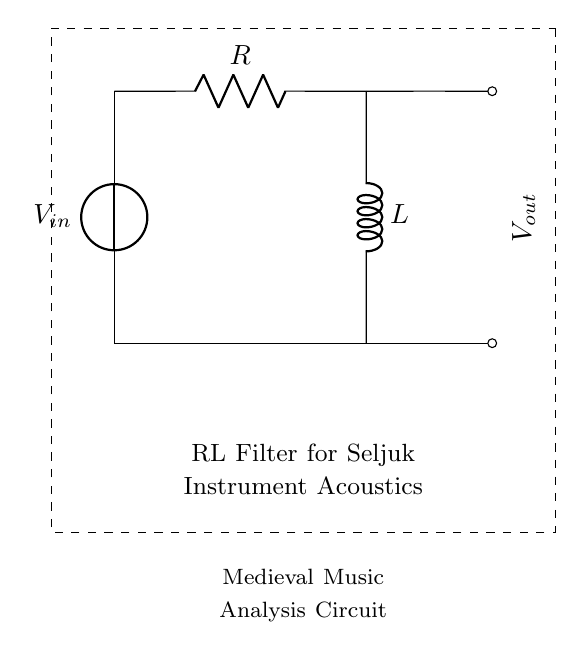What are the components in the circuit? In the circuit, the two primary components are a resistor and an inductor, as indicated by their respective symbols labeled R and L.
Answer: resistor and inductor What is the function of the resistor in this circuit? The resistor in an RL circuit primarily limits the current flowing through the circuit and affects the time constant of the filter response.
Answer: limit current What is the function of the inductor in the circuit? The inductor stores energy in a magnetic field when current flows through it and it resists changes in the current, impacting the circuit's frequency response.
Answer: store energy What is the relationship between the input voltage and output voltage? The output voltage is affected by the input voltage and the impedance of both the resistor and inductor, determining the filter characteristics such as gain and phase shift.
Answer: impedance dependent How does the circuit behave at different frequencies? At low frequencies, the inductor presents high impedance, reducing the output voltage; at high frequencies, its impedance decreases, allowing more signal to pass through effectively.
Answer: frequency dependent What type of filter does this circuit represent? This circuit represents a low-pass filter, allowing low-frequency signals to pass while attenuating high-frequency signals.
Answer: low-pass filter 